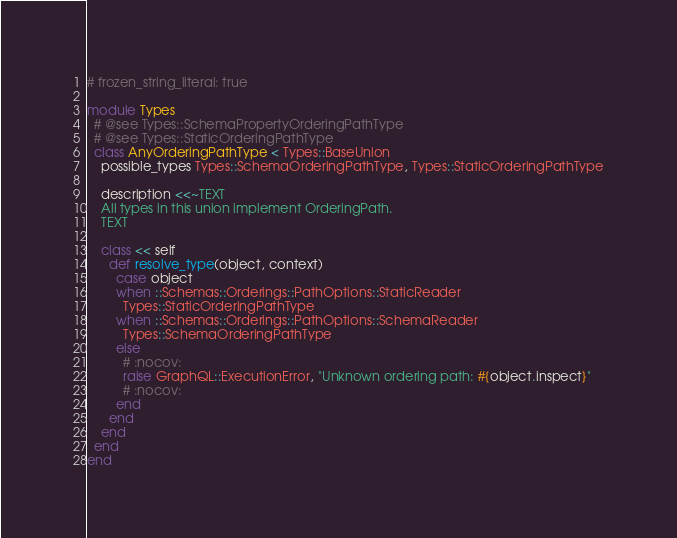Convert code to text. <code><loc_0><loc_0><loc_500><loc_500><_Ruby_># frozen_string_literal: true

module Types
  # @see Types::SchemaPropertyOrderingPathType
  # @see Types::StaticOrderingPathType
  class AnyOrderingPathType < Types::BaseUnion
    possible_types Types::SchemaOrderingPathType, Types::StaticOrderingPathType

    description <<~TEXT
    All types in this union implement OrderingPath.
    TEXT

    class << self
      def resolve_type(object, context)
        case object
        when ::Schemas::Orderings::PathOptions::StaticReader
          Types::StaticOrderingPathType
        when ::Schemas::Orderings::PathOptions::SchemaReader
          Types::SchemaOrderingPathType
        else
          # :nocov:
          raise GraphQL::ExecutionError, "Unknown ordering path: #{object.inspect}"
          # :nocov:
        end
      end
    end
  end
end
</code> 